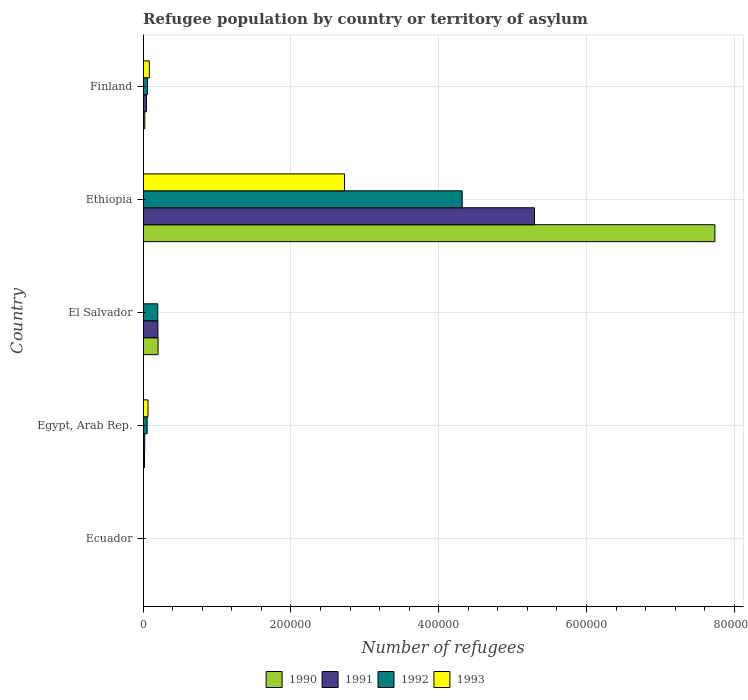How many different coloured bars are there?
Your answer should be compact. 4. How many groups of bars are there?
Keep it short and to the point. 5. Are the number of bars per tick equal to the number of legend labels?
Ensure brevity in your answer.  Yes. Are the number of bars on each tick of the Y-axis equal?
Give a very brief answer. Yes. How many bars are there on the 5th tick from the top?
Provide a succinct answer. 4. How many bars are there on the 4th tick from the bottom?
Keep it short and to the point. 4. What is the label of the 3rd group of bars from the top?
Keep it short and to the point. El Salvador. What is the number of refugees in 1993 in Ecuador?
Ensure brevity in your answer.  238. Across all countries, what is the maximum number of refugees in 1993?
Your answer should be compact. 2.73e+05. Across all countries, what is the minimum number of refugees in 1991?
Offer a terse response. 280. In which country was the number of refugees in 1991 maximum?
Your answer should be compact. Ethiopia. In which country was the number of refugees in 1993 minimum?
Ensure brevity in your answer.  El Salvador. What is the total number of refugees in 1991 in the graph?
Your answer should be compact. 5.57e+05. What is the difference between the number of refugees in 1993 in El Salvador and that in Finland?
Your answer should be compact. -8348. What is the difference between the number of refugees in 1992 in Egypt, Arab Rep. and the number of refugees in 1991 in Ethiopia?
Make the answer very short. -5.24e+05. What is the average number of refugees in 1992 per country?
Ensure brevity in your answer.  9.27e+04. What is the difference between the number of refugees in 1990 and number of refugees in 1993 in Ethiopia?
Offer a terse response. 5.01e+05. What is the ratio of the number of refugees in 1991 in El Salvador to that in Ethiopia?
Your answer should be compact. 0.04. What is the difference between the highest and the second highest number of refugees in 1993?
Offer a terse response. 2.64e+05. What is the difference between the highest and the lowest number of refugees in 1991?
Provide a short and direct response. 5.29e+05. In how many countries, is the number of refugees in 1990 greater than the average number of refugees in 1990 taken over all countries?
Offer a very short reply. 1. Is the sum of the number of refugees in 1992 in El Salvador and Finland greater than the maximum number of refugees in 1993 across all countries?
Your answer should be very brief. No. What does the 2nd bar from the top in Egypt, Arab Rep. represents?
Keep it short and to the point. 1992. What does the 2nd bar from the bottom in Finland represents?
Ensure brevity in your answer.  1991. Is it the case that in every country, the sum of the number of refugees in 1992 and number of refugees in 1991 is greater than the number of refugees in 1990?
Offer a terse response. No. How many bars are there?
Your answer should be very brief. 20. Are all the bars in the graph horizontal?
Provide a short and direct response. Yes. How many countries are there in the graph?
Provide a short and direct response. 5. Does the graph contain any zero values?
Give a very brief answer. No. Where does the legend appear in the graph?
Your answer should be very brief. Bottom center. How are the legend labels stacked?
Ensure brevity in your answer.  Horizontal. What is the title of the graph?
Provide a succinct answer. Refugee population by country or territory of asylum. Does "1995" appear as one of the legend labels in the graph?
Your answer should be very brief. No. What is the label or title of the X-axis?
Keep it short and to the point. Number of refugees. What is the label or title of the Y-axis?
Make the answer very short. Country. What is the Number of refugees in 1990 in Ecuador?
Give a very brief answer. 510. What is the Number of refugees of 1991 in Ecuador?
Give a very brief answer. 280. What is the Number of refugees in 1992 in Ecuador?
Offer a terse response. 204. What is the Number of refugees in 1993 in Ecuador?
Make the answer very short. 238. What is the Number of refugees of 1990 in Egypt, Arab Rep.?
Make the answer very short. 1991. What is the Number of refugees of 1991 in Egypt, Arab Rep.?
Offer a very short reply. 2245. What is the Number of refugees in 1992 in Egypt, Arab Rep.?
Provide a succinct answer. 5509. What is the Number of refugees of 1993 in Egypt, Arab Rep.?
Ensure brevity in your answer.  6712. What is the Number of refugees in 1990 in El Salvador?
Offer a terse response. 2.03e+04. What is the Number of refugees in 1991 in El Salvador?
Provide a short and direct response. 2.01e+04. What is the Number of refugees of 1992 in El Salvador?
Keep it short and to the point. 1.99e+04. What is the Number of refugees in 1993 in El Salvador?
Keep it short and to the point. 163. What is the Number of refugees of 1990 in Ethiopia?
Your answer should be very brief. 7.74e+05. What is the Number of refugees of 1991 in Ethiopia?
Give a very brief answer. 5.30e+05. What is the Number of refugees in 1992 in Ethiopia?
Your answer should be compact. 4.32e+05. What is the Number of refugees in 1993 in Ethiopia?
Offer a very short reply. 2.73e+05. What is the Number of refugees of 1990 in Finland?
Give a very brief answer. 2348. What is the Number of refugees in 1991 in Finland?
Your answer should be very brief. 4561. What is the Number of refugees of 1992 in Finland?
Offer a very short reply. 5950. What is the Number of refugees in 1993 in Finland?
Provide a succinct answer. 8511. Across all countries, what is the maximum Number of refugees in 1990?
Give a very brief answer. 7.74e+05. Across all countries, what is the maximum Number of refugees of 1991?
Make the answer very short. 5.30e+05. Across all countries, what is the maximum Number of refugees in 1992?
Your answer should be very brief. 4.32e+05. Across all countries, what is the maximum Number of refugees of 1993?
Give a very brief answer. 2.73e+05. Across all countries, what is the minimum Number of refugees in 1990?
Offer a terse response. 510. Across all countries, what is the minimum Number of refugees of 1991?
Offer a terse response. 280. Across all countries, what is the minimum Number of refugees in 1992?
Your answer should be very brief. 204. Across all countries, what is the minimum Number of refugees of 1993?
Ensure brevity in your answer.  163. What is the total Number of refugees in 1990 in the graph?
Make the answer very short. 7.99e+05. What is the total Number of refugees of 1991 in the graph?
Make the answer very short. 5.57e+05. What is the total Number of refugees in 1992 in the graph?
Your answer should be very brief. 4.63e+05. What is the total Number of refugees of 1993 in the graph?
Offer a very short reply. 2.88e+05. What is the difference between the Number of refugees of 1990 in Ecuador and that in Egypt, Arab Rep.?
Your answer should be compact. -1481. What is the difference between the Number of refugees in 1991 in Ecuador and that in Egypt, Arab Rep.?
Give a very brief answer. -1965. What is the difference between the Number of refugees of 1992 in Ecuador and that in Egypt, Arab Rep.?
Offer a very short reply. -5305. What is the difference between the Number of refugees of 1993 in Ecuador and that in Egypt, Arab Rep.?
Provide a short and direct response. -6474. What is the difference between the Number of refugees in 1990 in Ecuador and that in El Salvador?
Offer a terse response. -1.98e+04. What is the difference between the Number of refugees in 1991 in Ecuador and that in El Salvador?
Your answer should be compact. -1.98e+04. What is the difference between the Number of refugees in 1992 in Ecuador and that in El Salvador?
Your answer should be compact. -1.97e+04. What is the difference between the Number of refugees of 1993 in Ecuador and that in El Salvador?
Ensure brevity in your answer.  75. What is the difference between the Number of refugees of 1990 in Ecuador and that in Ethiopia?
Your response must be concise. -7.73e+05. What is the difference between the Number of refugees of 1991 in Ecuador and that in Ethiopia?
Ensure brevity in your answer.  -5.29e+05. What is the difference between the Number of refugees in 1992 in Ecuador and that in Ethiopia?
Provide a succinct answer. -4.32e+05. What is the difference between the Number of refugees in 1993 in Ecuador and that in Ethiopia?
Ensure brevity in your answer.  -2.72e+05. What is the difference between the Number of refugees of 1990 in Ecuador and that in Finland?
Your response must be concise. -1838. What is the difference between the Number of refugees in 1991 in Ecuador and that in Finland?
Offer a very short reply. -4281. What is the difference between the Number of refugees of 1992 in Ecuador and that in Finland?
Give a very brief answer. -5746. What is the difference between the Number of refugees in 1993 in Ecuador and that in Finland?
Offer a very short reply. -8273. What is the difference between the Number of refugees in 1990 in Egypt, Arab Rep. and that in El Salvador?
Your response must be concise. -1.83e+04. What is the difference between the Number of refugees in 1991 in Egypt, Arab Rep. and that in El Salvador?
Offer a very short reply. -1.79e+04. What is the difference between the Number of refugees of 1992 in Egypt, Arab Rep. and that in El Salvador?
Your answer should be very brief. -1.44e+04. What is the difference between the Number of refugees of 1993 in Egypt, Arab Rep. and that in El Salvador?
Make the answer very short. 6549. What is the difference between the Number of refugees in 1990 in Egypt, Arab Rep. and that in Ethiopia?
Give a very brief answer. -7.72e+05. What is the difference between the Number of refugees in 1991 in Egypt, Arab Rep. and that in Ethiopia?
Make the answer very short. -5.27e+05. What is the difference between the Number of refugees in 1992 in Egypt, Arab Rep. and that in Ethiopia?
Your answer should be compact. -4.26e+05. What is the difference between the Number of refugees in 1993 in Egypt, Arab Rep. and that in Ethiopia?
Give a very brief answer. -2.66e+05. What is the difference between the Number of refugees of 1990 in Egypt, Arab Rep. and that in Finland?
Make the answer very short. -357. What is the difference between the Number of refugees of 1991 in Egypt, Arab Rep. and that in Finland?
Your answer should be very brief. -2316. What is the difference between the Number of refugees of 1992 in Egypt, Arab Rep. and that in Finland?
Ensure brevity in your answer.  -441. What is the difference between the Number of refugees of 1993 in Egypt, Arab Rep. and that in Finland?
Your response must be concise. -1799. What is the difference between the Number of refugees in 1990 in El Salvador and that in Ethiopia?
Ensure brevity in your answer.  -7.53e+05. What is the difference between the Number of refugees of 1991 in El Salvador and that in Ethiopia?
Make the answer very short. -5.10e+05. What is the difference between the Number of refugees of 1992 in El Salvador and that in Ethiopia?
Offer a terse response. -4.12e+05. What is the difference between the Number of refugees in 1993 in El Salvador and that in Ethiopia?
Your response must be concise. -2.72e+05. What is the difference between the Number of refugees of 1990 in El Salvador and that in Finland?
Offer a terse response. 1.80e+04. What is the difference between the Number of refugees of 1991 in El Salvador and that in Finland?
Offer a very short reply. 1.55e+04. What is the difference between the Number of refugees of 1992 in El Salvador and that in Finland?
Offer a terse response. 1.40e+04. What is the difference between the Number of refugees of 1993 in El Salvador and that in Finland?
Offer a very short reply. -8348. What is the difference between the Number of refugees in 1990 in Ethiopia and that in Finland?
Your response must be concise. 7.71e+05. What is the difference between the Number of refugees of 1991 in Ethiopia and that in Finland?
Offer a very short reply. 5.25e+05. What is the difference between the Number of refugees of 1992 in Ethiopia and that in Finland?
Make the answer very short. 4.26e+05. What is the difference between the Number of refugees in 1993 in Ethiopia and that in Finland?
Make the answer very short. 2.64e+05. What is the difference between the Number of refugees in 1990 in Ecuador and the Number of refugees in 1991 in Egypt, Arab Rep.?
Give a very brief answer. -1735. What is the difference between the Number of refugees of 1990 in Ecuador and the Number of refugees of 1992 in Egypt, Arab Rep.?
Keep it short and to the point. -4999. What is the difference between the Number of refugees in 1990 in Ecuador and the Number of refugees in 1993 in Egypt, Arab Rep.?
Keep it short and to the point. -6202. What is the difference between the Number of refugees in 1991 in Ecuador and the Number of refugees in 1992 in Egypt, Arab Rep.?
Your answer should be compact. -5229. What is the difference between the Number of refugees of 1991 in Ecuador and the Number of refugees of 1993 in Egypt, Arab Rep.?
Offer a very short reply. -6432. What is the difference between the Number of refugees of 1992 in Ecuador and the Number of refugees of 1993 in Egypt, Arab Rep.?
Make the answer very short. -6508. What is the difference between the Number of refugees in 1990 in Ecuador and the Number of refugees in 1991 in El Salvador?
Keep it short and to the point. -1.96e+04. What is the difference between the Number of refugees of 1990 in Ecuador and the Number of refugees of 1992 in El Salvador?
Offer a terse response. -1.94e+04. What is the difference between the Number of refugees of 1990 in Ecuador and the Number of refugees of 1993 in El Salvador?
Offer a very short reply. 347. What is the difference between the Number of refugees of 1991 in Ecuador and the Number of refugees of 1992 in El Salvador?
Offer a terse response. -1.96e+04. What is the difference between the Number of refugees in 1991 in Ecuador and the Number of refugees in 1993 in El Salvador?
Keep it short and to the point. 117. What is the difference between the Number of refugees of 1990 in Ecuador and the Number of refugees of 1991 in Ethiopia?
Provide a succinct answer. -5.29e+05. What is the difference between the Number of refugees in 1990 in Ecuador and the Number of refugees in 1992 in Ethiopia?
Keep it short and to the point. -4.31e+05. What is the difference between the Number of refugees of 1990 in Ecuador and the Number of refugees of 1993 in Ethiopia?
Your answer should be compact. -2.72e+05. What is the difference between the Number of refugees of 1991 in Ecuador and the Number of refugees of 1992 in Ethiopia?
Offer a terse response. -4.32e+05. What is the difference between the Number of refugees of 1991 in Ecuador and the Number of refugees of 1993 in Ethiopia?
Give a very brief answer. -2.72e+05. What is the difference between the Number of refugees of 1992 in Ecuador and the Number of refugees of 1993 in Ethiopia?
Keep it short and to the point. -2.72e+05. What is the difference between the Number of refugees of 1990 in Ecuador and the Number of refugees of 1991 in Finland?
Offer a terse response. -4051. What is the difference between the Number of refugees in 1990 in Ecuador and the Number of refugees in 1992 in Finland?
Give a very brief answer. -5440. What is the difference between the Number of refugees of 1990 in Ecuador and the Number of refugees of 1993 in Finland?
Offer a very short reply. -8001. What is the difference between the Number of refugees of 1991 in Ecuador and the Number of refugees of 1992 in Finland?
Provide a succinct answer. -5670. What is the difference between the Number of refugees in 1991 in Ecuador and the Number of refugees in 1993 in Finland?
Give a very brief answer. -8231. What is the difference between the Number of refugees in 1992 in Ecuador and the Number of refugees in 1993 in Finland?
Give a very brief answer. -8307. What is the difference between the Number of refugees in 1990 in Egypt, Arab Rep. and the Number of refugees in 1991 in El Salvador?
Offer a terse response. -1.81e+04. What is the difference between the Number of refugees in 1990 in Egypt, Arab Rep. and the Number of refugees in 1992 in El Salvador?
Provide a short and direct response. -1.79e+04. What is the difference between the Number of refugees of 1990 in Egypt, Arab Rep. and the Number of refugees of 1993 in El Salvador?
Ensure brevity in your answer.  1828. What is the difference between the Number of refugees of 1991 in Egypt, Arab Rep. and the Number of refugees of 1992 in El Salvador?
Offer a terse response. -1.77e+04. What is the difference between the Number of refugees of 1991 in Egypt, Arab Rep. and the Number of refugees of 1993 in El Salvador?
Provide a short and direct response. 2082. What is the difference between the Number of refugees of 1992 in Egypt, Arab Rep. and the Number of refugees of 1993 in El Salvador?
Offer a very short reply. 5346. What is the difference between the Number of refugees in 1990 in Egypt, Arab Rep. and the Number of refugees in 1991 in Ethiopia?
Keep it short and to the point. -5.28e+05. What is the difference between the Number of refugees of 1990 in Egypt, Arab Rep. and the Number of refugees of 1992 in Ethiopia?
Your answer should be compact. -4.30e+05. What is the difference between the Number of refugees in 1990 in Egypt, Arab Rep. and the Number of refugees in 1993 in Ethiopia?
Provide a short and direct response. -2.71e+05. What is the difference between the Number of refugees of 1991 in Egypt, Arab Rep. and the Number of refugees of 1992 in Ethiopia?
Your answer should be compact. -4.30e+05. What is the difference between the Number of refugees in 1991 in Egypt, Arab Rep. and the Number of refugees in 1993 in Ethiopia?
Your response must be concise. -2.70e+05. What is the difference between the Number of refugees in 1992 in Egypt, Arab Rep. and the Number of refugees in 1993 in Ethiopia?
Make the answer very short. -2.67e+05. What is the difference between the Number of refugees of 1990 in Egypt, Arab Rep. and the Number of refugees of 1991 in Finland?
Provide a succinct answer. -2570. What is the difference between the Number of refugees of 1990 in Egypt, Arab Rep. and the Number of refugees of 1992 in Finland?
Your answer should be compact. -3959. What is the difference between the Number of refugees of 1990 in Egypt, Arab Rep. and the Number of refugees of 1993 in Finland?
Provide a succinct answer. -6520. What is the difference between the Number of refugees in 1991 in Egypt, Arab Rep. and the Number of refugees in 1992 in Finland?
Your answer should be very brief. -3705. What is the difference between the Number of refugees in 1991 in Egypt, Arab Rep. and the Number of refugees in 1993 in Finland?
Offer a terse response. -6266. What is the difference between the Number of refugees of 1992 in Egypt, Arab Rep. and the Number of refugees of 1993 in Finland?
Make the answer very short. -3002. What is the difference between the Number of refugees of 1990 in El Salvador and the Number of refugees of 1991 in Ethiopia?
Provide a succinct answer. -5.09e+05. What is the difference between the Number of refugees of 1990 in El Salvador and the Number of refugees of 1992 in Ethiopia?
Ensure brevity in your answer.  -4.12e+05. What is the difference between the Number of refugees of 1990 in El Salvador and the Number of refugees of 1993 in Ethiopia?
Offer a terse response. -2.52e+05. What is the difference between the Number of refugees of 1991 in El Salvador and the Number of refugees of 1992 in Ethiopia?
Offer a terse response. -4.12e+05. What is the difference between the Number of refugees of 1991 in El Salvador and the Number of refugees of 1993 in Ethiopia?
Your answer should be compact. -2.53e+05. What is the difference between the Number of refugees in 1992 in El Salvador and the Number of refugees in 1993 in Ethiopia?
Your answer should be very brief. -2.53e+05. What is the difference between the Number of refugees in 1990 in El Salvador and the Number of refugees in 1991 in Finland?
Your answer should be very brief. 1.57e+04. What is the difference between the Number of refugees of 1990 in El Salvador and the Number of refugees of 1992 in Finland?
Provide a short and direct response. 1.44e+04. What is the difference between the Number of refugees of 1990 in El Salvador and the Number of refugees of 1993 in Finland?
Your response must be concise. 1.18e+04. What is the difference between the Number of refugees of 1991 in El Salvador and the Number of refugees of 1992 in Finland?
Offer a very short reply. 1.41e+04. What is the difference between the Number of refugees of 1991 in El Salvador and the Number of refugees of 1993 in Finland?
Keep it short and to the point. 1.16e+04. What is the difference between the Number of refugees of 1992 in El Salvador and the Number of refugees of 1993 in Finland?
Provide a short and direct response. 1.14e+04. What is the difference between the Number of refugees in 1990 in Ethiopia and the Number of refugees in 1991 in Finland?
Your answer should be compact. 7.69e+05. What is the difference between the Number of refugees of 1990 in Ethiopia and the Number of refugees of 1992 in Finland?
Make the answer very short. 7.68e+05. What is the difference between the Number of refugees in 1990 in Ethiopia and the Number of refugees in 1993 in Finland?
Keep it short and to the point. 7.65e+05. What is the difference between the Number of refugees in 1991 in Ethiopia and the Number of refugees in 1992 in Finland?
Make the answer very short. 5.24e+05. What is the difference between the Number of refugees in 1991 in Ethiopia and the Number of refugees in 1993 in Finland?
Provide a succinct answer. 5.21e+05. What is the difference between the Number of refugees of 1992 in Ethiopia and the Number of refugees of 1993 in Finland?
Provide a short and direct response. 4.23e+05. What is the average Number of refugees of 1990 per country?
Your answer should be very brief. 1.60e+05. What is the average Number of refugees of 1991 per country?
Make the answer very short. 1.11e+05. What is the average Number of refugees in 1992 per country?
Make the answer very short. 9.27e+04. What is the average Number of refugees in 1993 per country?
Give a very brief answer. 5.77e+04. What is the difference between the Number of refugees in 1990 and Number of refugees in 1991 in Ecuador?
Provide a short and direct response. 230. What is the difference between the Number of refugees of 1990 and Number of refugees of 1992 in Ecuador?
Offer a terse response. 306. What is the difference between the Number of refugees of 1990 and Number of refugees of 1993 in Ecuador?
Keep it short and to the point. 272. What is the difference between the Number of refugees of 1991 and Number of refugees of 1992 in Ecuador?
Ensure brevity in your answer.  76. What is the difference between the Number of refugees in 1992 and Number of refugees in 1993 in Ecuador?
Give a very brief answer. -34. What is the difference between the Number of refugees in 1990 and Number of refugees in 1991 in Egypt, Arab Rep.?
Your answer should be compact. -254. What is the difference between the Number of refugees of 1990 and Number of refugees of 1992 in Egypt, Arab Rep.?
Your answer should be compact. -3518. What is the difference between the Number of refugees of 1990 and Number of refugees of 1993 in Egypt, Arab Rep.?
Ensure brevity in your answer.  -4721. What is the difference between the Number of refugees in 1991 and Number of refugees in 1992 in Egypt, Arab Rep.?
Keep it short and to the point. -3264. What is the difference between the Number of refugees in 1991 and Number of refugees in 1993 in Egypt, Arab Rep.?
Your response must be concise. -4467. What is the difference between the Number of refugees in 1992 and Number of refugees in 1993 in Egypt, Arab Rep.?
Give a very brief answer. -1203. What is the difference between the Number of refugees in 1990 and Number of refugees in 1991 in El Salvador?
Provide a succinct answer. 201. What is the difference between the Number of refugees of 1990 and Number of refugees of 1992 in El Salvador?
Make the answer very short. 397. What is the difference between the Number of refugees in 1990 and Number of refugees in 1993 in El Salvador?
Offer a terse response. 2.01e+04. What is the difference between the Number of refugees in 1991 and Number of refugees in 1992 in El Salvador?
Keep it short and to the point. 196. What is the difference between the Number of refugees of 1991 and Number of refugees of 1993 in El Salvador?
Make the answer very short. 1.99e+04. What is the difference between the Number of refugees of 1992 and Number of refugees of 1993 in El Salvador?
Your answer should be very brief. 1.97e+04. What is the difference between the Number of refugees of 1990 and Number of refugees of 1991 in Ethiopia?
Your response must be concise. 2.44e+05. What is the difference between the Number of refugees in 1990 and Number of refugees in 1992 in Ethiopia?
Offer a terse response. 3.42e+05. What is the difference between the Number of refugees of 1990 and Number of refugees of 1993 in Ethiopia?
Give a very brief answer. 5.01e+05. What is the difference between the Number of refugees of 1991 and Number of refugees of 1992 in Ethiopia?
Your answer should be compact. 9.78e+04. What is the difference between the Number of refugees in 1991 and Number of refugees in 1993 in Ethiopia?
Give a very brief answer. 2.57e+05. What is the difference between the Number of refugees in 1992 and Number of refugees in 1993 in Ethiopia?
Provide a short and direct response. 1.59e+05. What is the difference between the Number of refugees of 1990 and Number of refugees of 1991 in Finland?
Offer a very short reply. -2213. What is the difference between the Number of refugees of 1990 and Number of refugees of 1992 in Finland?
Give a very brief answer. -3602. What is the difference between the Number of refugees of 1990 and Number of refugees of 1993 in Finland?
Provide a succinct answer. -6163. What is the difference between the Number of refugees in 1991 and Number of refugees in 1992 in Finland?
Offer a very short reply. -1389. What is the difference between the Number of refugees of 1991 and Number of refugees of 1993 in Finland?
Offer a terse response. -3950. What is the difference between the Number of refugees in 1992 and Number of refugees in 1993 in Finland?
Make the answer very short. -2561. What is the ratio of the Number of refugees of 1990 in Ecuador to that in Egypt, Arab Rep.?
Your answer should be very brief. 0.26. What is the ratio of the Number of refugees of 1991 in Ecuador to that in Egypt, Arab Rep.?
Your answer should be compact. 0.12. What is the ratio of the Number of refugees in 1992 in Ecuador to that in Egypt, Arab Rep.?
Your response must be concise. 0.04. What is the ratio of the Number of refugees in 1993 in Ecuador to that in Egypt, Arab Rep.?
Provide a succinct answer. 0.04. What is the ratio of the Number of refugees of 1990 in Ecuador to that in El Salvador?
Provide a succinct answer. 0.03. What is the ratio of the Number of refugees of 1991 in Ecuador to that in El Salvador?
Your response must be concise. 0.01. What is the ratio of the Number of refugees in 1992 in Ecuador to that in El Salvador?
Make the answer very short. 0.01. What is the ratio of the Number of refugees of 1993 in Ecuador to that in El Salvador?
Offer a terse response. 1.46. What is the ratio of the Number of refugees in 1990 in Ecuador to that in Ethiopia?
Ensure brevity in your answer.  0. What is the ratio of the Number of refugees of 1991 in Ecuador to that in Ethiopia?
Your answer should be very brief. 0. What is the ratio of the Number of refugees in 1992 in Ecuador to that in Ethiopia?
Offer a terse response. 0. What is the ratio of the Number of refugees in 1993 in Ecuador to that in Ethiopia?
Ensure brevity in your answer.  0. What is the ratio of the Number of refugees of 1990 in Ecuador to that in Finland?
Your answer should be compact. 0.22. What is the ratio of the Number of refugees of 1991 in Ecuador to that in Finland?
Offer a very short reply. 0.06. What is the ratio of the Number of refugees of 1992 in Ecuador to that in Finland?
Your answer should be very brief. 0.03. What is the ratio of the Number of refugees in 1993 in Ecuador to that in Finland?
Your answer should be compact. 0.03. What is the ratio of the Number of refugees in 1990 in Egypt, Arab Rep. to that in El Salvador?
Make the answer very short. 0.1. What is the ratio of the Number of refugees in 1991 in Egypt, Arab Rep. to that in El Salvador?
Keep it short and to the point. 0.11. What is the ratio of the Number of refugees in 1992 in Egypt, Arab Rep. to that in El Salvador?
Your answer should be compact. 0.28. What is the ratio of the Number of refugees of 1993 in Egypt, Arab Rep. to that in El Salvador?
Provide a short and direct response. 41.18. What is the ratio of the Number of refugees of 1990 in Egypt, Arab Rep. to that in Ethiopia?
Provide a succinct answer. 0. What is the ratio of the Number of refugees in 1991 in Egypt, Arab Rep. to that in Ethiopia?
Give a very brief answer. 0. What is the ratio of the Number of refugees in 1992 in Egypt, Arab Rep. to that in Ethiopia?
Offer a terse response. 0.01. What is the ratio of the Number of refugees of 1993 in Egypt, Arab Rep. to that in Ethiopia?
Your answer should be compact. 0.02. What is the ratio of the Number of refugees of 1990 in Egypt, Arab Rep. to that in Finland?
Provide a succinct answer. 0.85. What is the ratio of the Number of refugees of 1991 in Egypt, Arab Rep. to that in Finland?
Provide a succinct answer. 0.49. What is the ratio of the Number of refugees in 1992 in Egypt, Arab Rep. to that in Finland?
Make the answer very short. 0.93. What is the ratio of the Number of refugees in 1993 in Egypt, Arab Rep. to that in Finland?
Your answer should be compact. 0.79. What is the ratio of the Number of refugees in 1990 in El Salvador to that in Ethiopia?
Provide a short and direct response. 0.03. What is the ratio of the Number of refugees in 1991 in El Salvador to that in Ethiopia?
Keep it short and to the point. 0.04. What is the ratio of the Number of refugees in 1992 in El Salvador to that in Ethiopia?
Ensure brevity in your answer.  0.05. What is the ratio of the Number of refugees in 1993 in El Salvador to that in Ethiopia?
Make the answer very short. 0. What is the ratio of the Number of refugees of 1990 in El Salvador to that in Finland?
Your answer should be compact. 8.65. What is the ratio of the Number of refugees of 1991 in El Salvador to that in Finland?
Provide a succinct answer. 4.41. What is the ratio of the Number of refugees in 1992 in El Salvador to that in Finland?
Provide a short and direct response. 3.35. What is the ratio of the Number of refugees of 1993 in El Salvador to that in Finland?
Give a very brief answer. 0.02. What is the ratio of the Number of refugees in 1990 in Ethiopia to that in Finland?
Ensure brevity in your answer.  329.54. What is the ratio of the Number of refugees of 1991 in Ethiopia to that in Finland?
Provide a succinct answer. 116.12. What is the ratio of the Number of refugees of 1992 in Ethiopia to that in Finland?
Keep it short and to the point. 72.58. What is the ratio of the Number of refugees in 1993 in Ethiopia to that in Finland?
Your answer should be compact. 32.03. What is the difference between the highest and the second highest Number of refugees of 1990?
Give a very brief answer. 7.53e+05. What is the difference between the highest and the second highest Number of refugees of 1991?
Offer a very short reply. 5.10e+05. What is the difference between the highest and the second highest Number of refugees of 1992?
Provide a succinct answer. 4.12e+05. What is the difference between the highest and the second highest Number of refugees of 1993?
Your response must be concise. 2.64e+05. What is the difference between the highest and the lowest Number of refugees of 1990?
Offer a terse response. 7.73e+05. What is the difference between the highest and the lowest Number of refugees in 1991?
Keep it short and to the point. 5.29e+05. What is the difference between the highest and the lowest Number of refugees of 1992?
Offer a very short reply. 4.32e+05. What is the difference between the highest and the lowest Number of refugees of 1993?
Provide a succinct answer. 2.72e+05. 